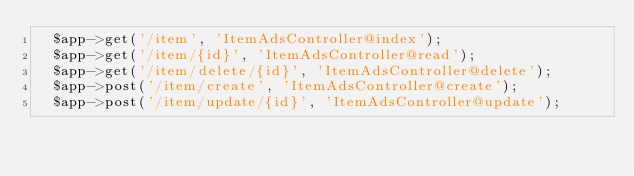Convert code to text. <code><loc_0><loc_0><loc_500><loc_500><_PHP_>  $app->get('/item', 'ItemAdsController@index');
  $app->get('/item/{id}', 'ItemAdsController@read');
  $app->get('/item/delete/{id}', 'ItemAdsController@delete');
  $app->post('/item/create', 'ItemAdsController@create');
  $app->post('/item/update/{id}', 'ItemAdsController@update');


</code> 